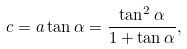<formula> <loc_0><loc_0><loc_500><loc_500>c = a \tan \alpha = \frac { \tan ^ { 2 } \alpha } { 1 + \tan \alpha } ,</formula> 